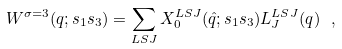Convert formula to latex. <formula><loc_0><loc_0><loc_500><loc_500>W ^ { \sigma = 3 } ( { q } ; s _ { 1 } s _ { 3 } ) = \sum _ { L S J } X ^ { L S J } _ { 0 } ( \hat { q } ; s _ { 1 } s _ { 3 } ) L ^ { L S J } _ { J } ( q ) \ ,</formula> 